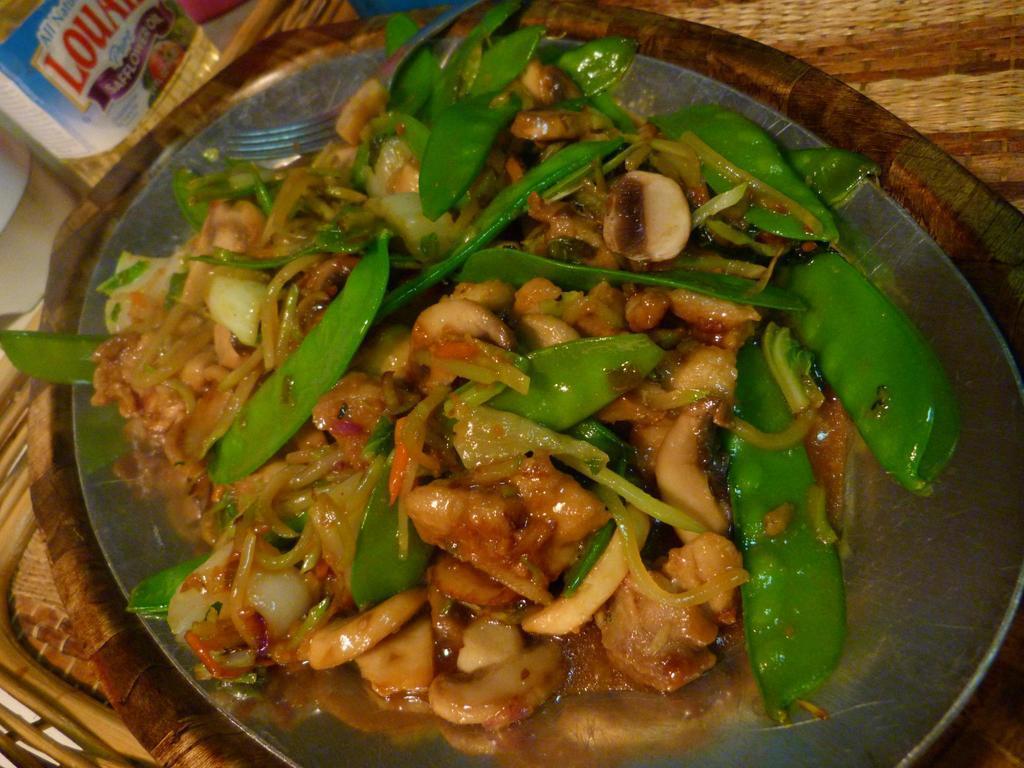Could you give a brief overview of what you see in this image? In this image, we can see some food and fork on the plate. Here we can see wooden objects. On the left side corner, we can see few things and sticker. 